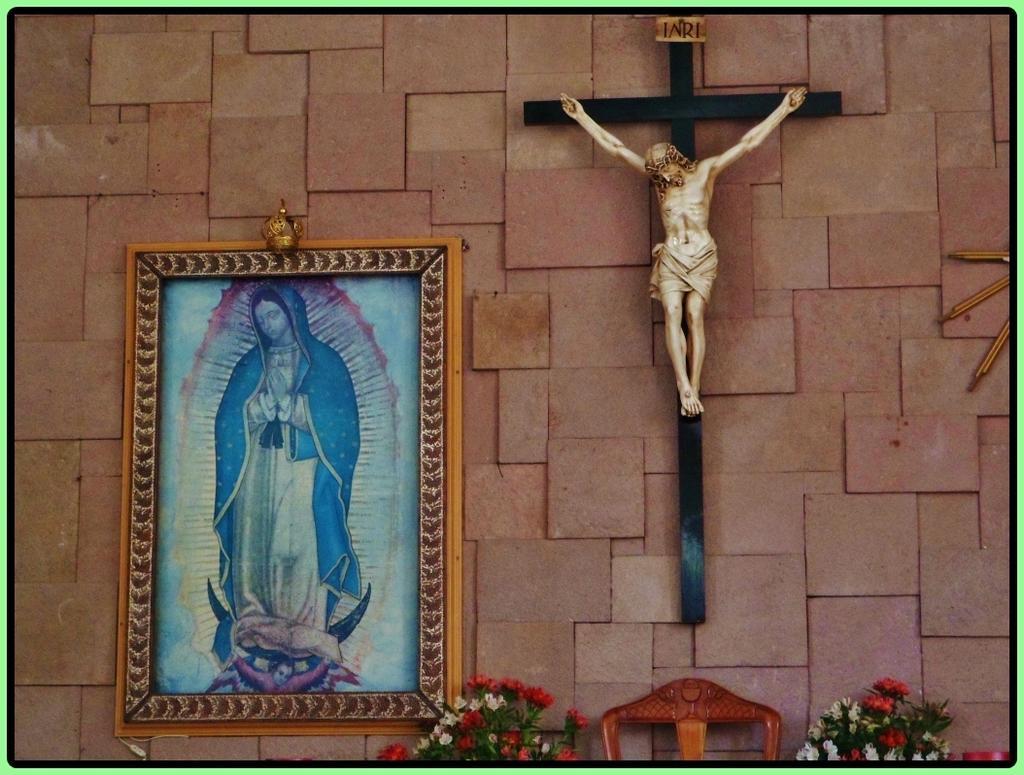Could you give a brief overview of what you see in this image? In this image I can see the wall and on it I can see a frame and a sculpture on the cross. On the bottom side of this image I can see few flowers and in the centre of it I can see a wooden thing. 